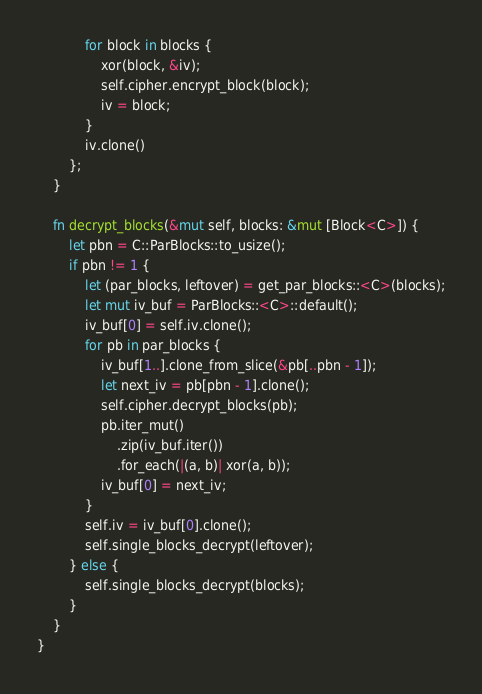<code> <loc_0><loc_0><loc_500><loc_500><_Rust_>            for block in blocks {
                xor(block, &iv);
                self.cipher.encrypt_block(block);
                iv = block;
            }
            iv.clone()
        };
    }

    fn decrypt_blocks(&mut self, blocks: &mut [Block<C>]) {
        let pbn = C::ParBlocks::to_usize();
        if pbn != 1 {
            let (par_blocks, leftover) = get_par_blocks::<C>(blocks);
            let mut iv_buf = ParBlocks::<C>::default();
            iv_buf[0] = self.iv.clone();
            for pb in par_blocks {
                iv_buf[1..].clone_from_slice(&pb[..pbn - 1]);
                let next_iv = pb[pbn - 1].clone();
                self.cipher.decrypt_blocks(pb);
                pb.iter_mut()
                    .zip(iv_buf.iter())
                    .for_each(|(a, b)| xor(a, b));
                iv_buf[0] = next_iv;
            }
            self.iv = iv_buf[0].clone();
            self.single_blocks_decrypt(leftover);
        } else {
            self.single_blocks_decrypt(blocks);
        }
    }
}
</code> 